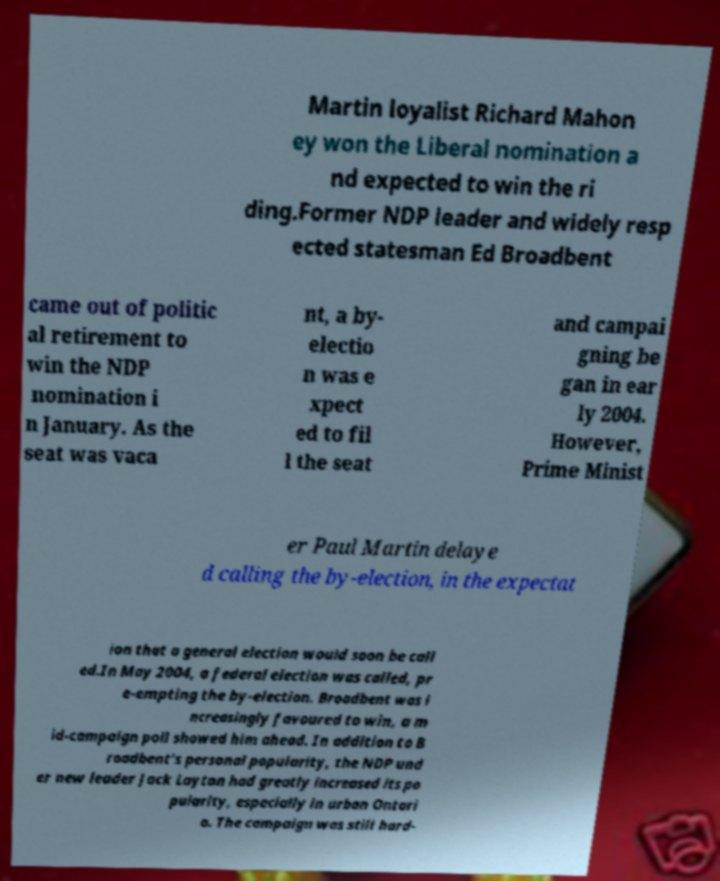What messages or text are displayed in this image? I need them in a readable, typed format. Martin loyalist Richard Mahon ey won the Liberal nomination a nd expected to win the ri ding.Former NDP leader and widely resp ected statesman Ed Broadbent came out of politic al retirement to win the NDP nomination i n January. As the seat was vaca nt, a by- electio n was e xpect ed to fil l the seat and campai gning be gan in ear ly 2004. However, Prime Minist er Paul Martin delaye d calling the by-election, in the expectat ion that a general election would soon be call ed.In May 2004, a federal election was called, pr e-empting the by-election. Broadbent was i ncreasingly favoured to win, a m id-campaign poll showed him ahead. In addition to B roadbent's personal popularity, the NDP und er new leader Jack Layton had greatly increased its po pularity, especially in urban Ontari o. The campaign was still hard- 